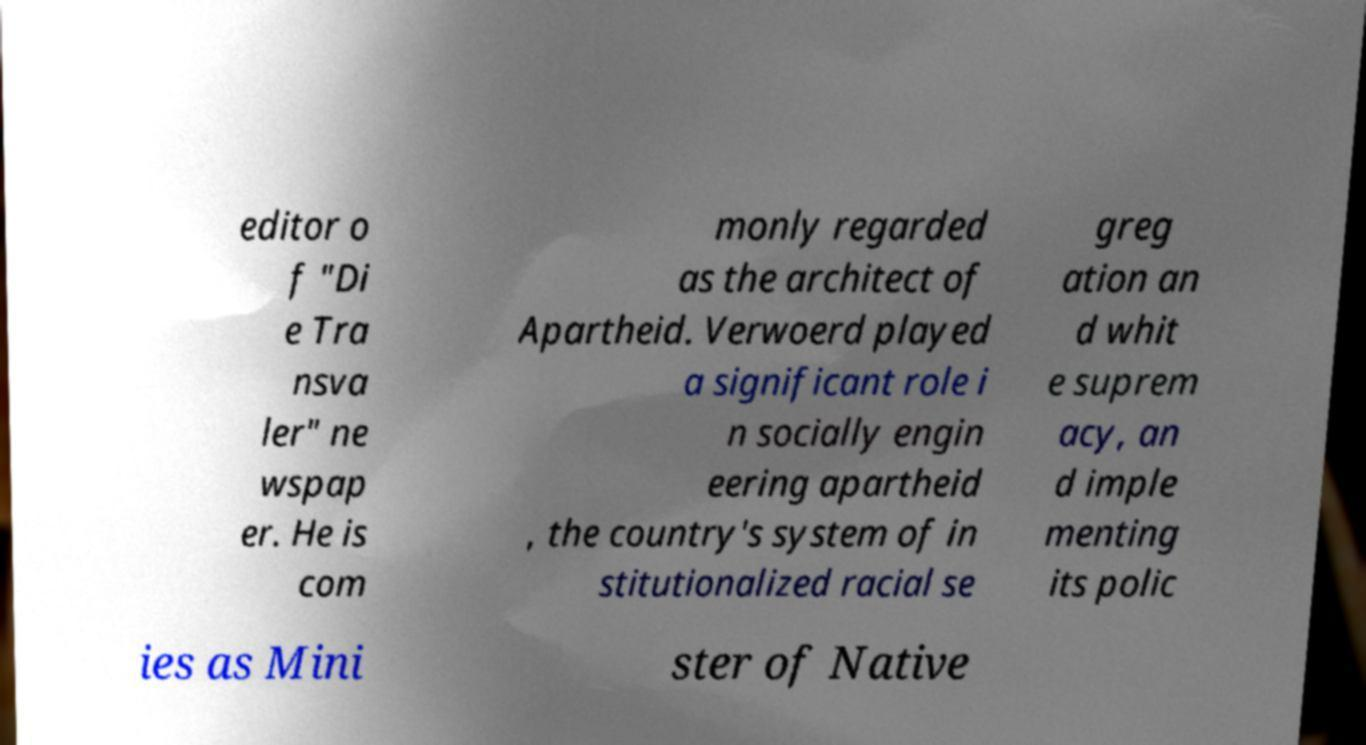Can you read and provide the text displayed in the image?This photo seems to have some interesting text. Can you extract and type it out for me? editor o f "Di e Tra nsva ler" ne wspap er. He is com monly regarded as the architect of Apartheid. Verwoerd played a significant role i n socially engin eering apartheid , the country's system of in stitutionalized racial se greg ation an d whit e suprem acy, an d imple menting its polic ies as Mini ster of Native 